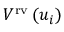Convert formula to latex. <formula><loc_0><loc_0><loc_500><loc_500>V ^ { r v } \left ( u _ { i } \right )</formula> 